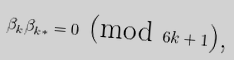<formula> <loc_0><loc_0><loc_500><loc_500>\beta _ { k } \beta _ { k \ast } = 0 \text { (mod } 6 k + 1 \text {),}</formula> 